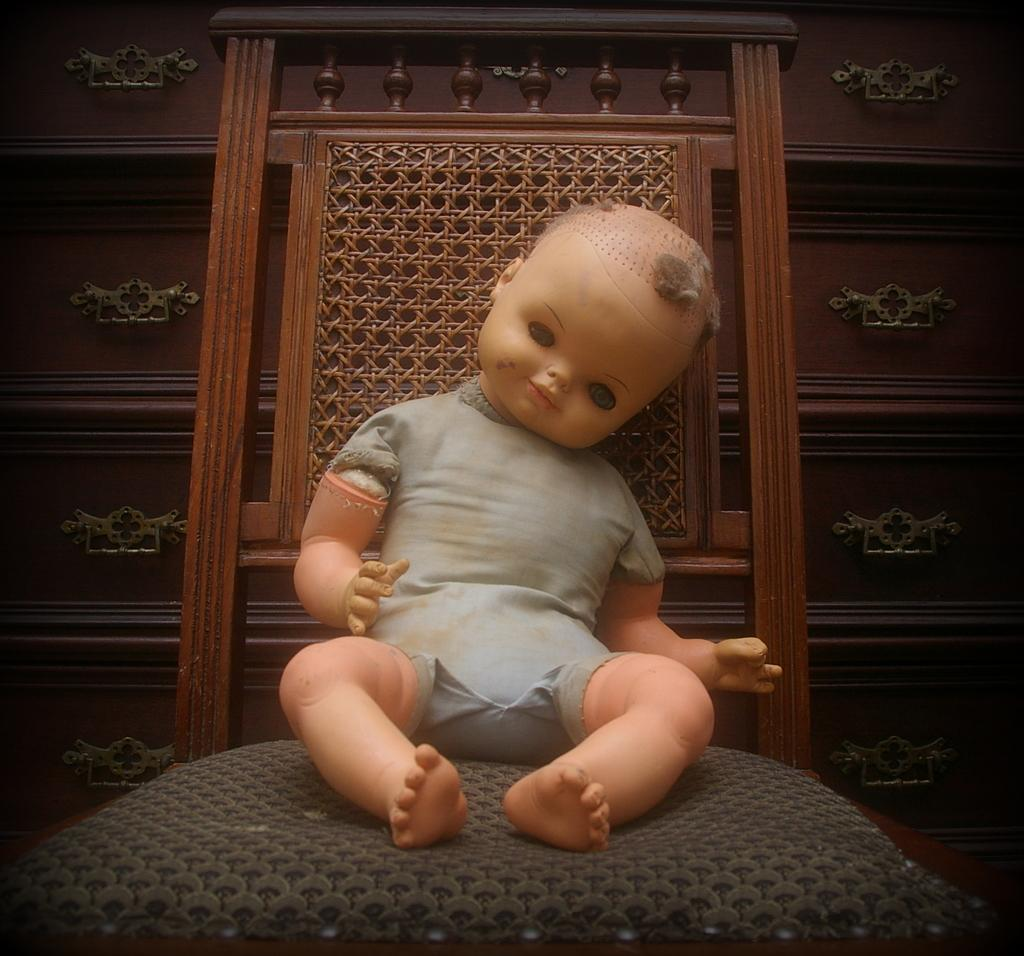What object can be seen in the image that is meant for play? There is a toy in the image. What piece of furniture is present in the image? There is a chair in the image. What material is used for the background in the image? The background of the image is wooden. What company is responsible for manufacturing the chair in the image? There is no information about the manufacturer of the chair in the image. Can you tell me how many chins are visible in the image? There are no faces or chins present in the image. 